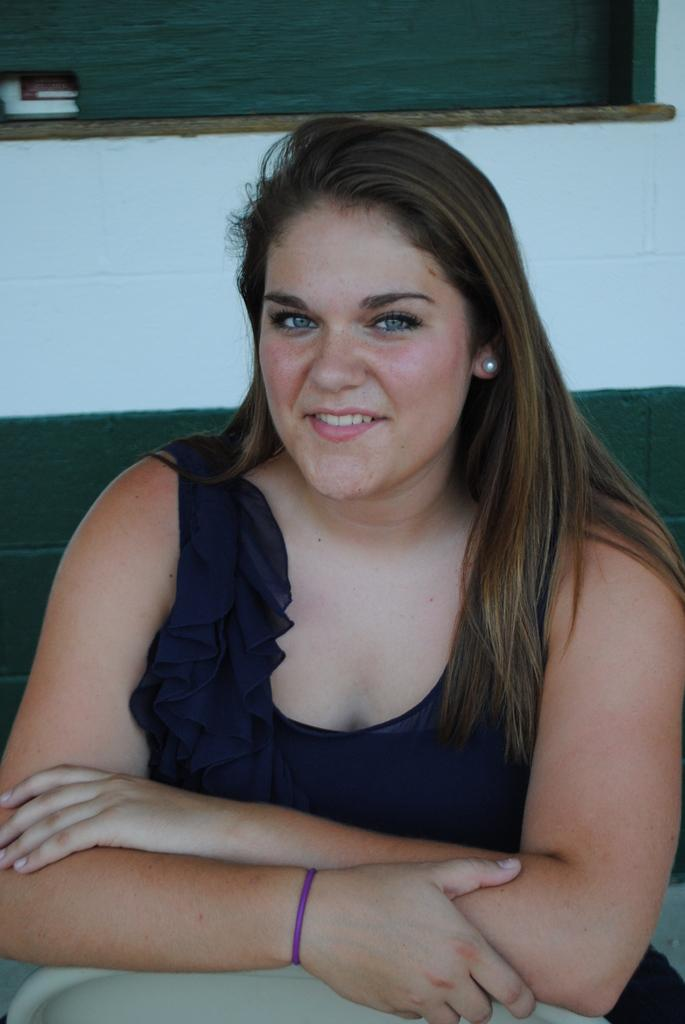Who is present in the image? There is a woman in the image. What is the woman doing in the image? The woman is sitting in the image. What is the woman's facial expression in the image? The woman is smiling in the image. What can be seen in the background of the image? There is a wall in the image. Can you confirm the presence of a window in the image? It is less certain, but there might be a window in the image. What type of flowers are on the cake that the woman is holding in the image? There is no cake or flowers present in the image; the woman is simply sitting and smiling. 